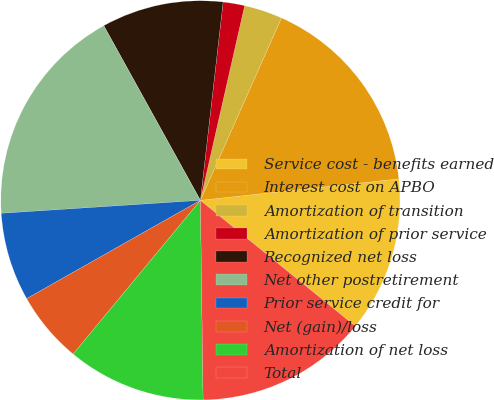<chart> <loc_0><loc_0><loc_500><loc_500><pie_chart><fcel>Service cost - benefits earned<fcel>Interest cost on APBO<fcel>Amortization of transition<fcel>Amortization of prior service<fcel>Recognized net loss<fcel>Net other postretirement<fcel>Prior service credit for<fcel>Net (gain)/loss<fcel>Amortization of net loss<fcel>Total<nl><fcel>12.57%<fcel>16.63%<fcel>3.1%<fcel>1.74%<fcel>9.86%<fcel>17.99%<fcel>7.16%<fcel>5.8%<fcel>11.22%<fcel>13.93%<nl></chart> 